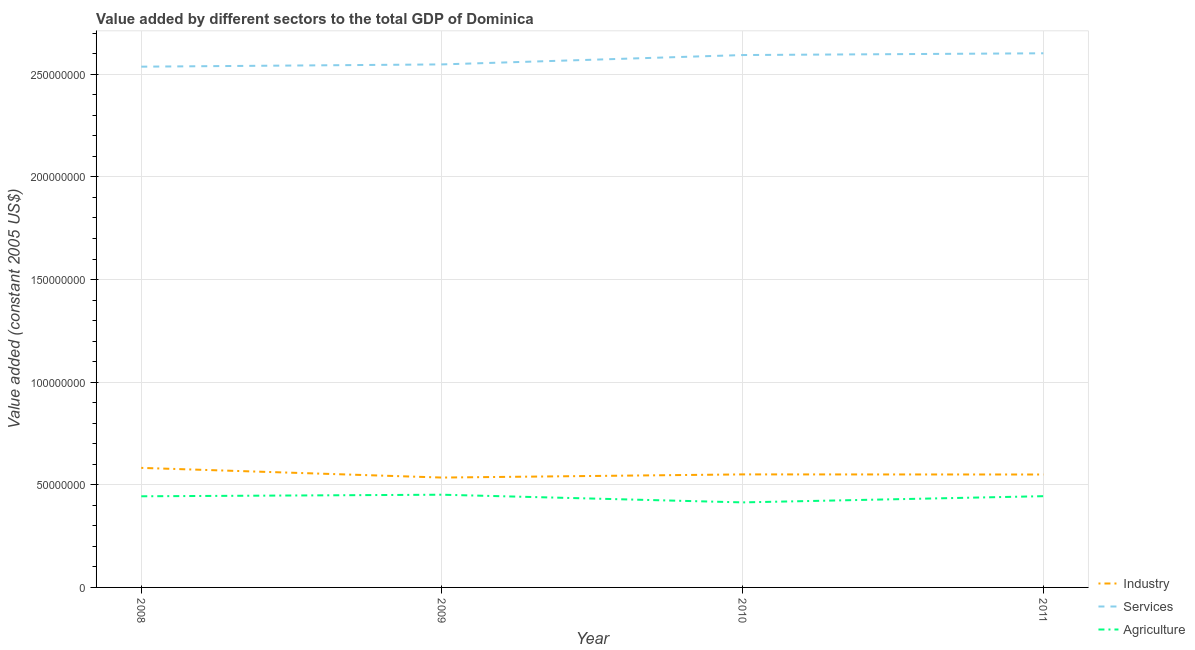Does the line corresponding to value added by industrial sector intersect with the line corresponding to value added by services?
Make the answer very short. No. Is the number of lines equal to the number of legend labels?
Make the answer very short. Yes. What is the value added by services in 2008?
Offer a very short reply. 2.54e+08. Across all years, what is the maximum value added by agricultural sector?
Your answer should be very brief. 4.52e+07. Across all years, what is the minimum value added by agricultural sector?
Ensure brevity in your answer.  4.14e+07. In which year was the value added by services minimum?
Ensure brevity in your answer.  2008. What is the total value added by agricultural sector in the graph?
Your response must be concise. 1.75e+08. What is the difference between the value added by agricultural sector in 2008 and that in 2011?
Provide a short and direct response. -5.48e+04. What is the difference between the value added by services in 2008 and the value added by industrial sector in 2009?
Give a very brief answer. 2.00e+08. What is the average value added by industrial sector per year?
Make the answer very short. 5.55e+07. In the year 2009, what is the difference between the value added by industrial sector and value added by agricultural sector?
Offer a terse response. 8.36e+06. In how many years, is the value added by agricultural sector greater than 120000000 US$?
Provide a short and direct response. 0. What is the ratio of the value added by services in 2009 to that in 2010?
Offer a terse response. 0.98. What is the difference between the highest and the second highest value added by agricultural sector?
Keep it short and to the point. 7.14e+05. What is the difference between the highest and the lowest value added by industrial sector?
Your answer should be compact. 4.72e+06. In how many years, is the value added by services greater than the average value added by services taken over all years?
Give a very brief answer. 2. Is the sum of the value added by services in 2009 and 2011 greater than the maximum value added by industrial sector across all years?
Your answer should be compact. Yes. Is it the case that in every year, the sum of the value added by industrial sector and value added by services is greater than the value added by agricultural sector?
Provide a succinct answer. Yes. Is the value added by agricultural sector strictly less than the value added by services over the years?
Your answer should be very brief. Yes. Does the graph contain any zero values?
Provide a short and direct response. No. How many legend labels are there?
Provide a succinct answer. 3. How are the legend labels stacked?
Provide a short and direct response. Vertical. What is the title of the graph?
Give a very brief answer. Value added by different sectors to the total GDP of Dominica. What is the label or title of the X-axis?
Offer a terse response. Year. What is the label or title of the Y-axis?
Keep it short and to the point. Value added (constant 2005 US$). What is the Value added (constant 2005 US$) in Industry in 2008?
Offer a very short reply. 5.82e+07. What is the Value added (constant 2005 US$) of Services in 2008?
Ensure brevity in your answer.  2.54e+08. What is the Value added (constant 2005 US$) in Agriculture in 2008?
Ensure brevity in your answer.  4.44e+07. What is the Value added (constant 2005 US$) of Industry in 2009?
Keep it short and to the point. 5.35e+07. What is the Value added (constant 2005 US$) of Services in 2009?
Provide a short and direct response. 2.55e+08. What is the Value added (constant 2005 US$) of Agriculture in 2009?
Keep it short and to the point. 4.52e+07. What is the Value added (constant 2005 US$) of Industry in 2010?
Your answer should be compact. 5.51e+07. What is the Value added (constant 2005 US$) of Services in 2010?
Provide a succinct answer. 2.59e+08. What is the Value added (constant 2005 US$) of Agriculture in 2010?
Your answer should be compact. 4.14e+07. What is the Value added (constant 2005 US$) in Industry in 2011?
Your response must be concise. 5.50e+07. What is the Value added (constant 2005 US$) of Services in 2011?
Ensure brevity in your answer.  2.60e+08. What is the Value added (constant 2005 US$) of Agriculture in 2011?
Your response must be concise. 4.45e+07. Across all years, what is the maximum Value added (constant 2005 US$) of Industry?
Provide a short and direct response. 5.82e+07. Across all years, what is the maximum Value added (constant 2005 US$) in Services?
Provide a succinct answer. 2.60e+08. Across all years, what is the maximum Value added (constant 2005 US$) of Agriculture?
Make the answer very short. 4.52e+07. Across all years, what is the minimum Value added (constant 2005 US$) in Industry?
Provide a short and direct response. 5.35e+07. Across all years, what is the minimum Value added (constant 2005 US$) in Services?
Your answer should be compact. 2.54e+08. Across all years, what is the minimum Value added (constant 2005 US$) of Agriculture?
Give a very brief answer. 4.14e+07. What is the total Value added (constant 2005 US$) in Industry in the graph?
Make the answer very short. 2.22e+08. What is the total Value added (constant 2005 US$) of Services in the graph?
Your answer should be very brief. 1.03e+09. What is the total Value added (constant 2005 US$) in Agriculture in the graph?
Offer a terse response. 1.75e+08. What is the difference between the Value added (constant 2005 US$) of Industry in 2008 and that in 2009?
Give a very brief answer. 4.72e+06. What is the difference between the Value added (constant 2005 US$) of Services in 2008 and that in 2009?
Offer a very short reply. -1.10e+06. What is the difference between the Value added (constant 2005 US$) of Agriculture in 2008 and that in 2009?
Keep it short and to the point. -7.69e+05. What is the difference between the Value added (constant 2005 US$) in Industry in 2008 and that in 2010?
Your response must be concise. 3.18e+06. What is the difference between the Value added (constant 2005 US$) in Services in 2008 and that in 2010?
Provide a short and direct response. -5.67e+06. What is the difference between the Value added (constant 2005 US$) in Agriculture in 2008 and that in 2010?
Give a very brief answer. 2.97e+06. What is the difference between the Value added (constant 2005 US$) of Industry in 2008 and that in 2011?
Provide a short and direct response. 3.23e+06. What is the difference between the Value added (constant 2005 US$) in Services in 2008 and that in 2011?
Your answer should be very brief. -6.52e+06. What is the difference between the Value added (constant 2005 US$) in Agriculture in 2008 and that in 2011?
Make the answer very short. -5.48e+04. What is the difference between the Value added (constant 2005 US$) in Industry in 2009 and that in 2010?
Provide a succinct answer. -1.54e+06. What is the difference between the Value added (constant 2005 US$) in Services in 2009 and that in 2010?
Your answer should be compact. -4.56e+06. What is the difference between the Value added (constant 2005 US$) of Agriculture in 2009 and that in 2010?
Ensure brevity in your answer.  3.74e+06. What is the difference between the Value added (constant 2005 US$) of Industry in 2009 and that in 2011?
Make the answer very short. -1.49e+06. What is the difference between the Value added (constant 2005 US$) in Services in 2009 and that in 2011?
Keep it short and to the point. -5.42e+06. What is the difference between the Value added (constant 2005 US$) of Agriculture in 2009 and that in 2011?
Provide a short and direct response. 7.14e+05. What is the difference between the Value added (constant 2005 US$) of Industry in 2010 and that in 2011?
Provide a succinct answer. 5.16e+04. What is the difference between the Value added (constant 2005 US$) in Services in 2010 and that in 2011?
Your answer should be compact. -8.58e+05. What is the difference between the Value added (constant 2005 US$) in Agriculture in 2010 and that in 2011?
Ensure brevity in your answer.  -3.03e+06. What is the difference between the Value added (constant 2005 US$) of Industry in 2008 and the Value added (constant 2005 US$) of Services in 2009?
Offer a very short reply. -1.97e+08. What is the difference between the Value added (constant 2005 US$) of Industry in 2008 and the Value added (constant 2005 US$) of Agriculture in 2009?
Your response must be concise. 1.31e+07. What is the difference between the Value added (constant 2005 US$) of Services in 2008 and the Value added (constant 2005 US$) of Agriculture in 2009?
Offer a terse response. 2.09e+08. What is the difference between the Value added (constant 2005 US$) of Industry in 2008 and the Value added (constant 2005 US$) of Services in 2010?
Make the answer very short. -2.01e+08. What is the difference between the Value added (constant 2005 US$) in Industry in 2008 and the Value added (constant 2005 US$) in Agriculture in 2010?
Provide a short and direct response. 1.68e+07. What is the difference between the Value added (constant 2005 US$) of Services in 2008 and the Value added (constant 2005 US$) of Agriculture in 2010?
Make the answer very short. 2.12e+08. What is the difference between the Value added (constant 2005 US$) in Industry in 2008 and the Value added (constant 2005 US$) in Services in 2011?
Provide a short and direct response. -2.02e+08. What is the difference between the Value added (constant 2005 US$) of Industry in 2008 and the Value added (constant 2005 US$) of Agriculture in 2011?
Your answer should be very brief. 1.38e+07. What is the difference between the Value added (constant 2005 US$) in Services in 2008 and the Value added (constant 2005 US$) in Agriculture in 2011?
Offer a very short reply. 2.09e+08. What is the difference between the Value added (constant 2005 US$) of Industry in 2009 and the Value added (constant 2005 US$) of Services in 2010?
Your response must be concise. -2.06e+08. What is the difference between the Value added (constant 2005 US$) in Industry in 2009 and the Value added (constant 2005 US$) in Agriculture in 2010?
Offer a terse response. 1.21e+07. What is the difference between the Value added (constant 2005 US$) in Services in 2009 and the Value added (constant 2005 US$) in Agriculture in 2010?
Keep it short and to the point. 2.13e+08. What is the difference between the Value added (constant 2005 US$) of Industry in 2009 and the Value added (constant 2005 US$) of Services in 2011?
Offer a terse response. -2.07e+08. What is the difference between the Value added (constant 2005 US$) in Industry in 2009 and the Value added (constant 2005 US$) in Agriculture in 2011?
Keep it short and to the point. 9.07e+06. What is the difference between the Value added (constant 2005 US$) of Services in 2009 and the Value added (constant 2005 US$) of Agriculture in 2011?
Keep it short and to the point. 2.10e+08. What is the difference between the Value added (constant 2005 US$) of Industry in 2010 and the Value added (constant 2005 US$) of Services in 2011?
Make the answer very short. -2.05e+08. What is the difference between the Value added (constant 2005 US$) of Industry in 2010 and the Value added (constant 2005 US$) of Agriculture in 2011?
Offer a very short reply. 1.06e+07. What is the difference between the Value added (constant 2005 US$) in Services in 2010 and the Value added (constant 2005 US$) in Agriculture in 2011?
Provide a succinct answer. 2.15e+08. What is the average Value added (constant 2005 US$) of Industry per year?
Keep it short and to the point. 5.55e+07. What is the average Value added (constant 2005 US$) of Services per year?
Keep it short and to the point. 2.57e+08. What is the average Value added (constant 2005 US$) of Agriculture per year?
Keep it short and to the point. 4.39e+07. In the year 2008, what is the difference between the Value added (constant 2005 US$) in Industry and Value added (constant 2005 US$) in Services?
Provide a short and direct response. -1.95e+08. In the year 2008, what is the difference between the Value added (constant 2005 US$) in Industry and Value added (constant 2005 US$) in Agriculture?
Provide a succinct answer. 1.38e+07. In the year 2008, what is the difference between the Value added (constant 2005 US$) of Services and Value added (constant 2005 US$) of Agriculture?
Keep it short and to the point. 2.09e+08. In the year 2009, what is the difference between the Value added (constant 2005 US$) in Industry and Value added (constant 2005 US$) in Services?
Your answer should be compact. -2.01e+08. In the year 2009, what is the difference between the Value added (constant 2005 US$) of Industry and Value added (constant 2005 US$) of Agriculture?
Offer a very short reply. 8.36e+06. In the year 2009, what is the difference between the Value added (constant 2005 US$) in Services and Value added (constant 2005 US$) in Agriculture?
Your answer should be compact. 2.10e+08. In the year 2010, what is the difference between the Value added (constant 2005 US$) in Industry and Value added (constant 2005 US$) in Services?
Your answer should be compact. -2.04e+08. In the year 2010, what is the difference between the Value added (constant 2005 US$) in Industry and Value added (constant 2005 US$) in Agriculture?
Give a very brief answer. 1.36e+07. In the year 2010, what is the difference between the Value added (constant 2005 US$) of Services and Value added (constant 2005 US$) of Agriculture?
Make the answer very short. 2.18e+08. In the year 2011, what is the difference between the Value added (constant 2005 US$) of Industry and Value added (constant 2005 US$) of Services?
Make the answer very short. -2.05e+08. In the year 2011, what is the difference between the Value added (constant 2005 US$) in Industry and Value added (constant 2005 US$) in Agriculture?
Keep it short and to the point. 1.06e+07. In the year 2011, what is the difference between the Value added (constant 2005 US$) of Services and Value added (constant 2005 US$) of Agriculture?
Provide a succinct answer. 2.16e+08. What is the ratio of the Value added (constant 2005 US$) in Industry in 2008 to that in 2009?
Offer a very short reply. 1.09. What is the ratio of the Value added (constant 2005 US$) of Services in 2008 to that in 2009?
Make the answer very short. 1. What is the ratio of the Value added (constant 2005 US$) in Industry in 2008 to that in 2010?
Your answer should be very brief. 1.06. What is the ratio of the Value added (constant 2005 US$) of Services in 2008 to that in 2010?
Your answer should be compact. 0.98. What is the ratio of the Value added (constant 2005 US$) of Agriculture in 2008 to that in 2010?
Offer a very short reply. 1.07. What is the ratio of the Value added (constant 2005 US$) of Industry in 2008 to that in 2011?
Offer a very short reply. 1.06. What is the ratio of the Value added (constant 2005 US$) in Services in 2008 to that in 2011?
Offer a very short reply. 0.97. What is the ratio of the Value added (constant 2005 US$) of Agriculture in 2008 to that in 2011?
Give a very brief answer. 1. What is the ratio of the Value added (constant 2005 US$) of Industry in 2009 to that in 2010?
Provide a succinct answer. 0.97. What is the ratio of the Value added (constant 2005 US$) of Services in 2009 to that in 2010?
Your answer should be compact. 0.98. What is the ratio of the Value added (constant 2005 US$) in Agriculture in 2009 to that in 2010?
Keep it short and to the point. 1.09. What is the ratio of the Value added (constant 2005 US$) of Services in 2009 to that in 2011?
Make the answer very short. 0.98. What is the ratio of the Value added (constant 2005 US$) of Agriculture in 2009 to that in 2011?
Offer a very short reply. 1.02. What is the ratio of the Value added (constant 2005 US$) in Services in 2010 to that in 2011?
Keep it short and to the point. 1. What is the ratio of the Value added (constant 2005 US$) of Agriculture in 2010 to that in 2011?
Offer a very short reply. 0.93. What is the difference between the highest and the second highest Value added (constant 2005 US$) in Industry?
Provide a short and direct response. 3.18e+06. What is the difference between the highest and the second highest Value added (constant 2005 US$) of Services?
Keep it short and to the point. 8.58e+05. What is the difference between the highest and the second highest Value added (constant 2005 US$) of Agriculture?
Ensure brevity in your answer.  7.14e+05. What is the difference between the highest and the lowest Value added (constant 2005 US$) of Industry?
Your answer should be very brief. 4.72e+06. What is the difference between the highest and the lowest Value added (constant 2005 US$) in Services?
Provide a short and direct response. 6.52e+06. What is the difference between the highest and the lowest Value added (constant 2005 US$) in Agriculture?
Give a very brief answer. 3.74e+06. 